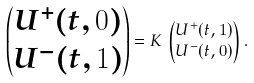<formula> <loc_0><loc_0><loc_500><loc_500>\begin{pmatrix} U ^ { + } ( t , 0 ) \\ U ^ { - } ( t , 1 ) \end{pmatrix} & = K \, \begin{pmatrix} U ^ { + } ( t , 1 ) \\ U ^ { - } ( t , 0 ) \end{pmatrix} .</formula> 